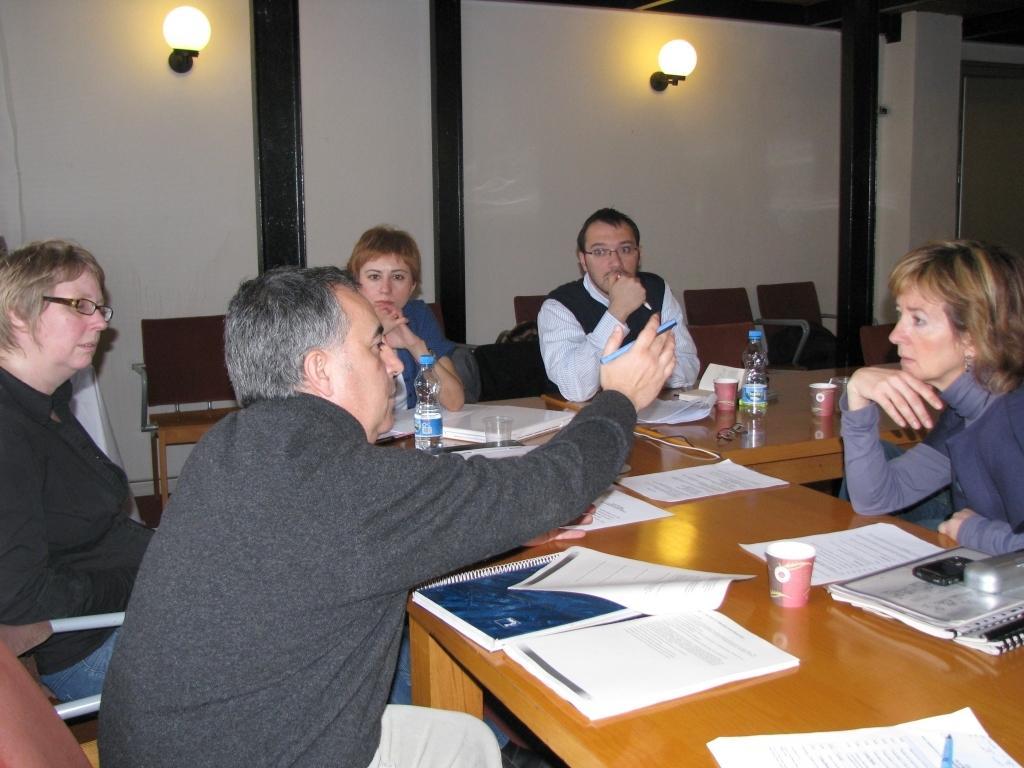How would you summarize this image in a sentence or two? In the center of the image there are people sitting on chairs. There is a table on which there are objects. In the background of the image there is wall with lights. 